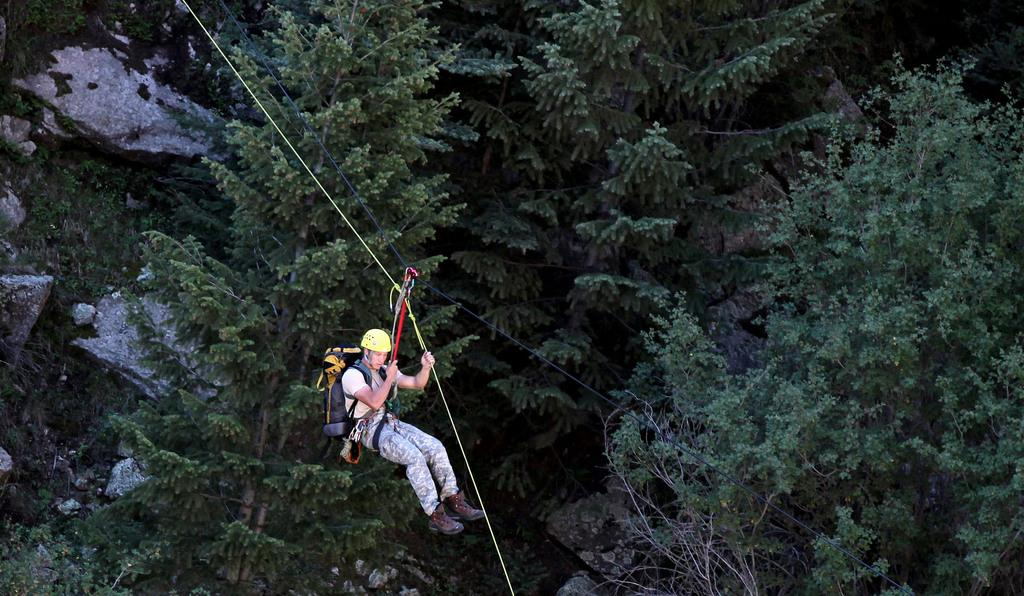What is the person in the image doing? There is a person riding on the ropeway in the image. What can be seen in the background of the image? There are rocks and trees visible in the background of the image. What type of drum can be heard playing in the background of the image? There is no drum or sound present in the image; it is a still image of a person riding on a ropeway with rocks and trees in the background. 